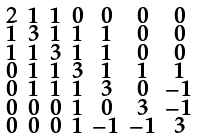Convert formula to latex. <formula><loc_0><loc_0><loc_500><loc_500>\begin{smallmatrix} 2 & 1 & 1 & 0 & 0 & 0 & 0 \\ 1 & 3 & 1 & 1 & 1 & 0 & 0 \\ 1 & 1 & 3 & 1 & 1 & 0 & 0 \\ 0 & 1 & 1 & 3 & 1 & 1 & 1 \\ 0 & 1 & 1 & 1 & 3 & 0 & - 1 \\ 0 & 0 & 0 & 1 & 0 & 3 & - 1 \\ 0 & 0 & 0 & 1 & - 1 & - 1 & 3 \end{smallmatrix}</formula> 